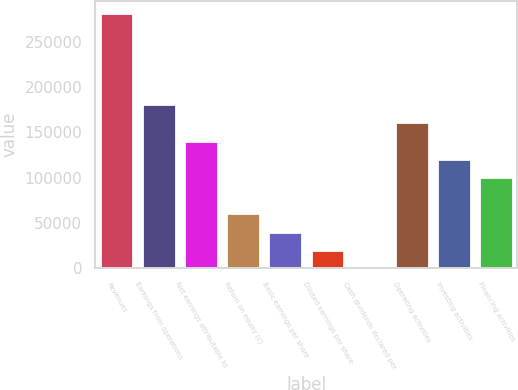<chart> <loc_0><loc_0><loc_500><loc_500><bar_chart><fcel>Revenues<fcel>Earnings from operations<fcel>Net earnings attributable to<fcel>Return on equity (c)<fcel>Basic earnings per share<fcel>Diluted earnings per share<fcel>Cash dividends declared per<fcel>Operating activities<fcel>Investing activities<fcel>Financing activities<nl><fcel>281621<fcel>181043<fcel>140812<fcel>60349.7<fcel>40234.1<fcel>20118.5<fcel>2.88<fcel>160928<fcel>120697<fcel>100581<nl></chart> 